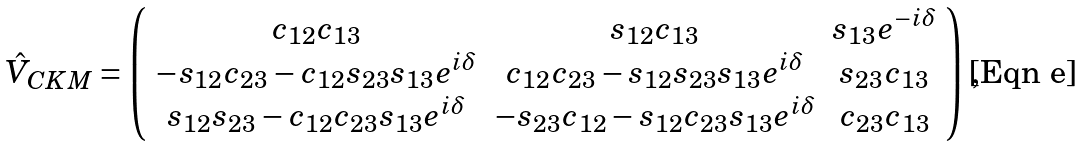<formula> <loc_0><loc_0><loc_500><loc_500>\hat { V } _ { C K M } = \left ( \begin{array} { c c c } c _ { 1 2 } c _ { 1 3 } & s _ { 1 2 } c _ { 1 3 } & s _ { 1 3 } e ^ { - i \delta } \\ - s _ { 1 2 } c _ { 2 3 } - c _ { 1 2 } s _ { 2 3 } s _ { 1 3 } e ^ { i \delta } & c _ { 1 2 } c _ { 2 3 } - s _ { 1 2 } s _ { 2 3 } s _ { 1 3 } e ^ { i \delta } & s _ { 2 3 } c _ { 1 3 } \\ s _ { 1 2 } s _ { 2 3 } - c _ { 1 2 } c _ { 2 3 } s _ { 1 3 } e ^ { i \delta } & - s _ { 2 3 } c _ { 1 2 } - s _ { 1 2 } c _ { 2 3 } s _ { 1 3 } e ^ { i \delta } & c _ { 2 3 } c _ { 1 3 } \end{array} \right ) \, ,</formula> 